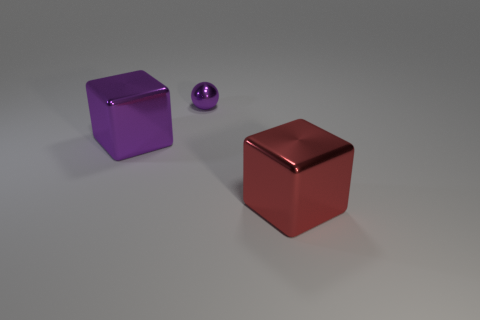Add 2 tiny metal things. How many objects exist? 5 Subtract all purple blocks. How many blocks are left? 1 Subtract all cubes. How many objects are left? 1 Subtract all brown balls. Subtract all purple blocks. How many balls are left? 1 Subtract all gray cubes. How many brown balls are left? 0 Add 2 tiny purple spheres. How many tiny purple spheres are left? 3 Add 1 big metallic cubes. How many big metallic cubes exist? 3 Subtract 1 purple balls. How many objects are left? 2 Subtract all large red metal spheres. Subtract all metal balls. How many objects are left? 2 